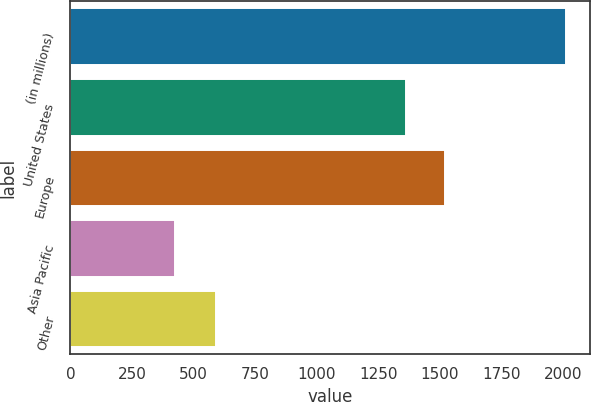Convert chart. <chart><loc_0><loc_0><loc_500><loc_500><bar_chart><fcel>(in millions)<fcel>United States<fcel>Europe<fcel>Asia Pacific<fcel>Other<nl><fcel>2011<fcel>1363<fcel>1521.5<fcel>426<fcel>592<nl></chart> 